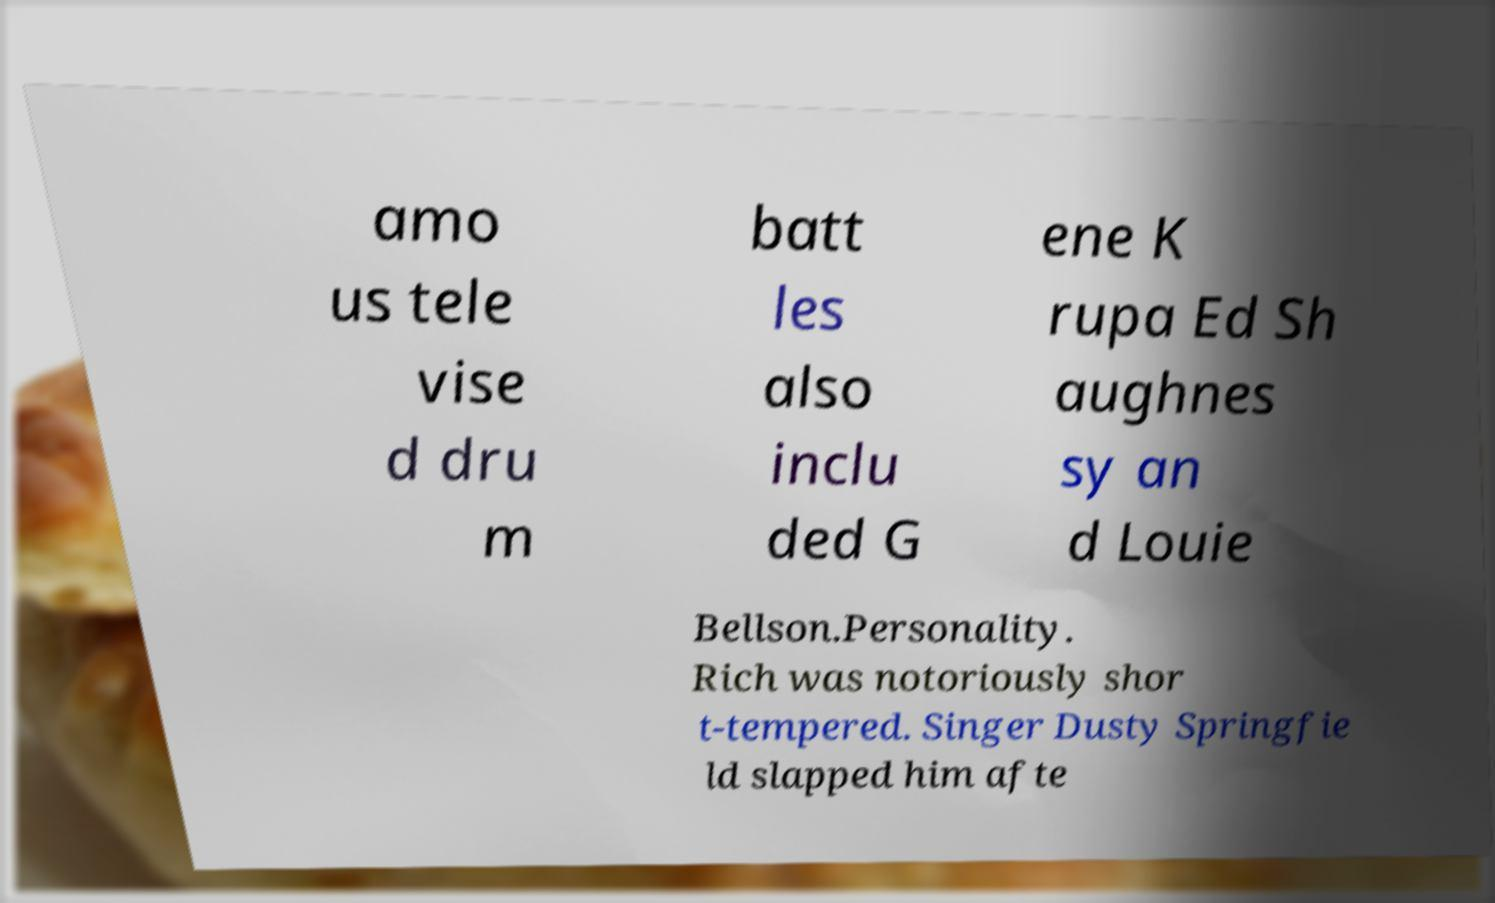Please read and relay the text visible in this image. What does it say? amo us tele vise d dru m batt les also inclu ded G ene K rupa Ed Sh aughnes sy an d Louie Bellson.Personality. Rich was notoriously shor t-tempered. Singer Dusty Springfie ld slapped him afte 